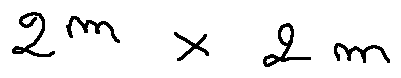<formula> <loc_0><loc_0><loc_500><loc_500>2 ^ { m } \times 2 m</formula> 